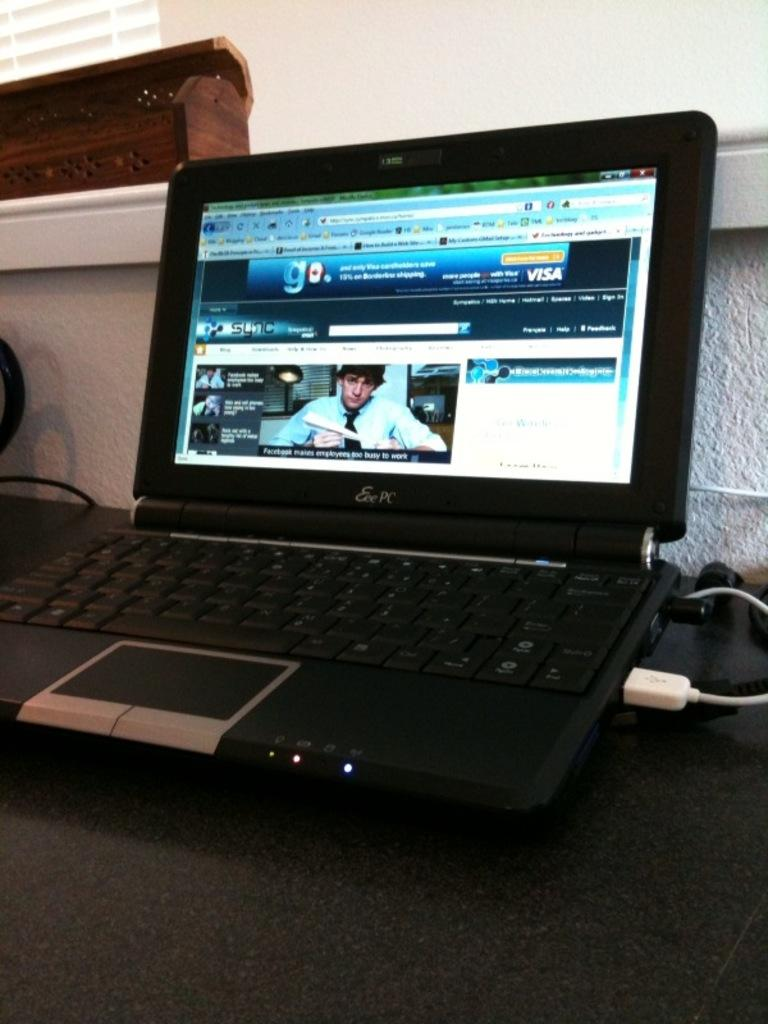Provide a one-sentence caption for the provided image. An Eee PC with the Sync website opened on the monitor. 